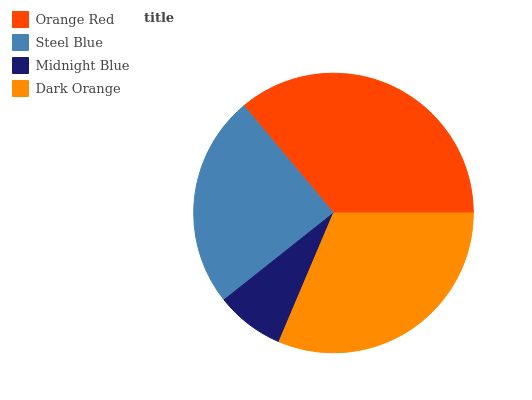Is Midnight Blue the minimum?
Answer yes or no. Yes. Is Orange Red the maximum?
Answer yes or no. Yes. Is Steel Blue the minimum?
Answer yes or no. No. Is Steel Blue the maximum?
Answer yes or no. No. Is Orange Red greater than Steel Blue?
Answer yes or no. Yes. Is Steel Blue less than Orange Red?
Answer yes or no. Yes. Is Steel Blue greater than Orange Red?
Answer yes or no. No. Is Orange Red less than Steel Blue?
Answer yes or no. No. Is Dark Orange the high median?
Answer yes or no. Yes. Is Steel Blue the low median?
Answer yes or no. Yes. Is Steel Blue the high median?
Answer yes or no. No. Is Orange Red the low median?
Answer yes or no. No. 